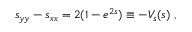<formula> <loc_0><loc_0><loc_500><loc_500>s _ { y y } - s _ { x x } = 2 ( 1 - e ^ { 2 s } ) \equiv - V _ { s } ( s ) ,</formula> 